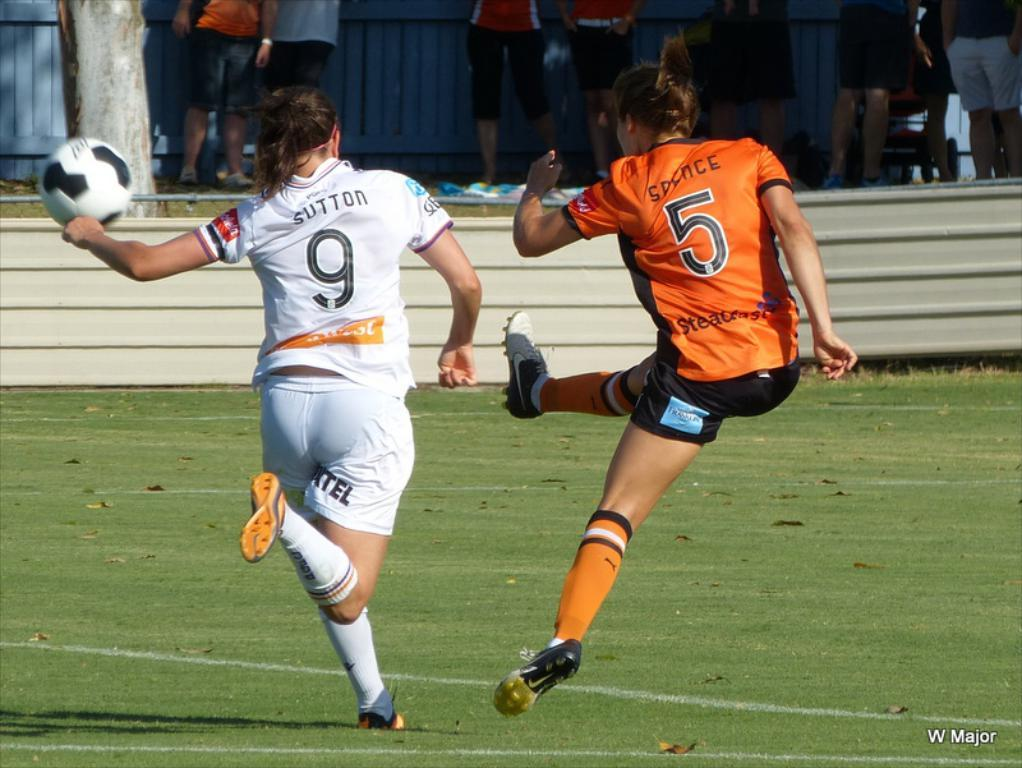<image>
Share a concise interpretation of the image provided. Two soccer players go for the ball and number 9 appears to have just kicked it. 